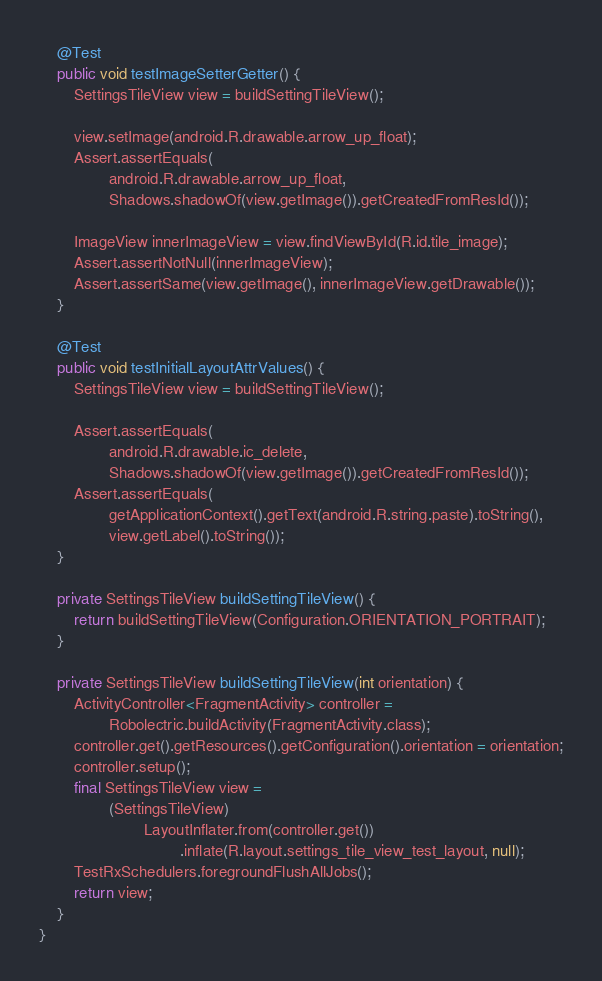<code> <loc_0><loc_0><loc_500><loc_500><_Java_>    @Test
    public void testImageSetterGetter() {
        SettingsTileView view = buildSettingTileView();

        view.setImage(android.R.drawable.arrow_up_float);
        Assert.assertEquals(
                android.R.drawable.arrow_up_float,
                Shadows.shadowOf(view.getImage()).getCreatedFromResId());

        ImageView innerImageView = view.findViewById(R.id.tile_image);
        Assert.assertNotNull(innerImageView);
        Assert.assertSame(view.getImage(), innerImageView.getDrawable());
    }

    @Test
    public void testInitialLayoutAttrValues() {
        SettingsTileView view = buildSettingTileView();

        Assert.assertEquals(
                android.R.drawable.ic_delete,
                Shadows.shadowOf(view.getImage()).getCreatedFromResId());
        Assert.assertEquals(
                getApplicationContext().getText(android.R.string.paste).toString(),
                view.getLabel().toString());
    }

    private SettingsTileView buildSettingTileView() {
        return buildSettingTileView(Configuration.ORIENTATION_PORTRAIT);
    }

    private SettingsTileView buildSettingTileView(int orientation) {
        ActivityController<FragmentActivity> controller =
                Robolectric.buildActivity(FragmentActivity.class);
        controller.get().getResources().getConfiguration().orientation = orientation;
        controller.setup();
        final SettingsTileView view =
                (SettingsTileView)
                        LayoutInflater.from(controller.get())
                                .inflate(R.layout.settings_tile_view_test_layout, null);
        TestRxSchedulers.foregroundFlushAllJobs();
        return view;
    }
}
</code> 